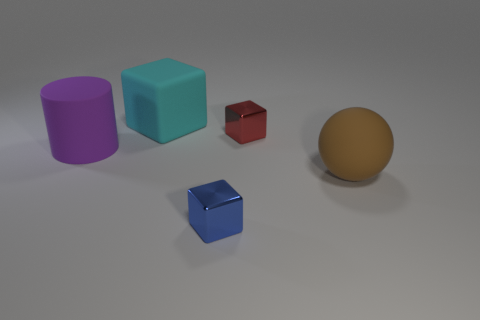Add 3 small purple rubber spheres. How many objects exist? 8 Subtract all cubes. How many objects are left? 2 Add 3 cylinders. How many cylinders are left? 4 Add 2 red spheres. How many red spheres exist? 2 Subtract 1 blue blocks. How many objects are left? 4 Subtract all red shiny cubes. Subtract all big cyan rubber cubes. How many objects are left? 3 